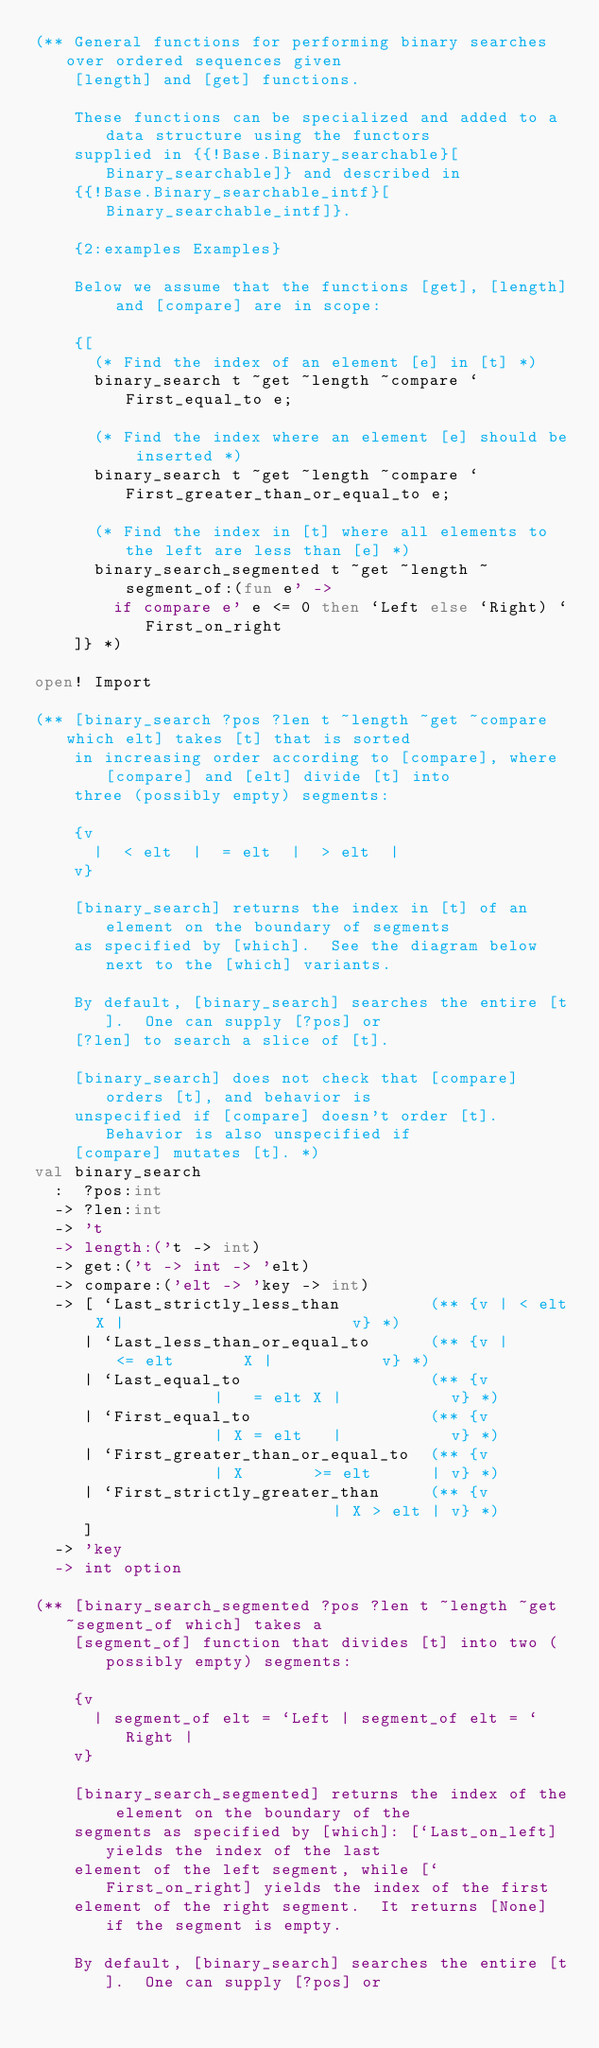Convert code to text. <code><loc_0><loc_0><loc_500><loc_500><_OCaml_>(** General functions for performing binary searches over ordered sequences given
    [length] and [get] functions.

    These functions can be specialized and added to a data structure using the functors
    supplied in {{!Base.Binary_searchable}[Binary_searchable]} and described in
    {{!Base.Binary_searchable_intf}[Binary_searchable_intf]}.

    {2:examples Examples}

    Below we assume that the functions [get], [length] and [compare] are in scope:

    {[
      (* Find the index of an element [e] in [t] *)
      binary_search t ~get ~length ~compare `First_equal_to e;

      (* Find the index where an element [e] should be inserted *)
      binary_search t ~get ~length ~compare `First_greater_than_or_equal_to e;

      (* Find the index in [t] where all elements to the left are less than [e] *)
      binary_search_segmented t ~get ~length ~segment_of:(fun e' ->
        if compare e' e <= 0 then `Left else `Right) `First_on_right
    ]} *)

open! Import

(** [binary_search ?pos ?len t ~length ~get ~compare which elt] takes [t] that is sorted
    in increasing order according to [compare], where [compare] and [elt] divide [t] into
    three (possibly empty) segments:

    {v
      |  < elt  |  = elt  |  > elt  |
    v}

    [binary_search] returns the index in [t] of an element on the boundary of segments
    as specified by [which].  See the diagram below next to the [which] variants.

    By default, [binary_search] searches the entire [t].  One can supply [?pos] or
    [?len] to search a slice of [t].

    [binary_search] does not check that [compare] orders [t], and behavior is
    unspecified if [compare] doesn't order [t].  Behavior is also unspecified if
    [compare] mutates [t]. *)
val binary_search
  :  ?pos:int
  -> ?len:int
  -> 't
  -> length:('t -> int)
  -> get:('t -> int -> 'elt)
  -> compare:('elt -> 'key -> int)
  -> [ `Last_strictly_less_than         (** {v | < elt X |                       v} *)
     | `Last_less_than_or_equal_to      (** {v |      <= elt       X |           v} *)
     | `Last_equal_to                   (** {v           |   = elt X |           v} *)
     | `First_equal_to                  (** {v           | X = elt   |           v} *)
     | `First_greater_than_or_equal_to  (** {v           | X       >= elt      | v} *)
     | `First_strictly_greater_than     (** {v                       | X > elt | v} *)
     ]
  -> 'key
  -> int option

(** [binary_search_segmented ?pos ?len t ~length ~get ~segment_of which] takes a
    [segment_of] function that divides [t] into two (possibly empty) segments:

    {v
      | segment_of elt = `Left | segment_of elt = `Right |
    v}

    [binary_search_segmented] returns the index of the element on the boundary of the
    segments as specified by [which]: [`Last_on_left] yields the index of the last
    element of the left segment, while [`First_on_right] yields the index of the first
    element of the right segment.  It returns [None] if the segment is empty.

    By default, [binary_search] searches the entire [t].  One can supply [?pos] or</code> 